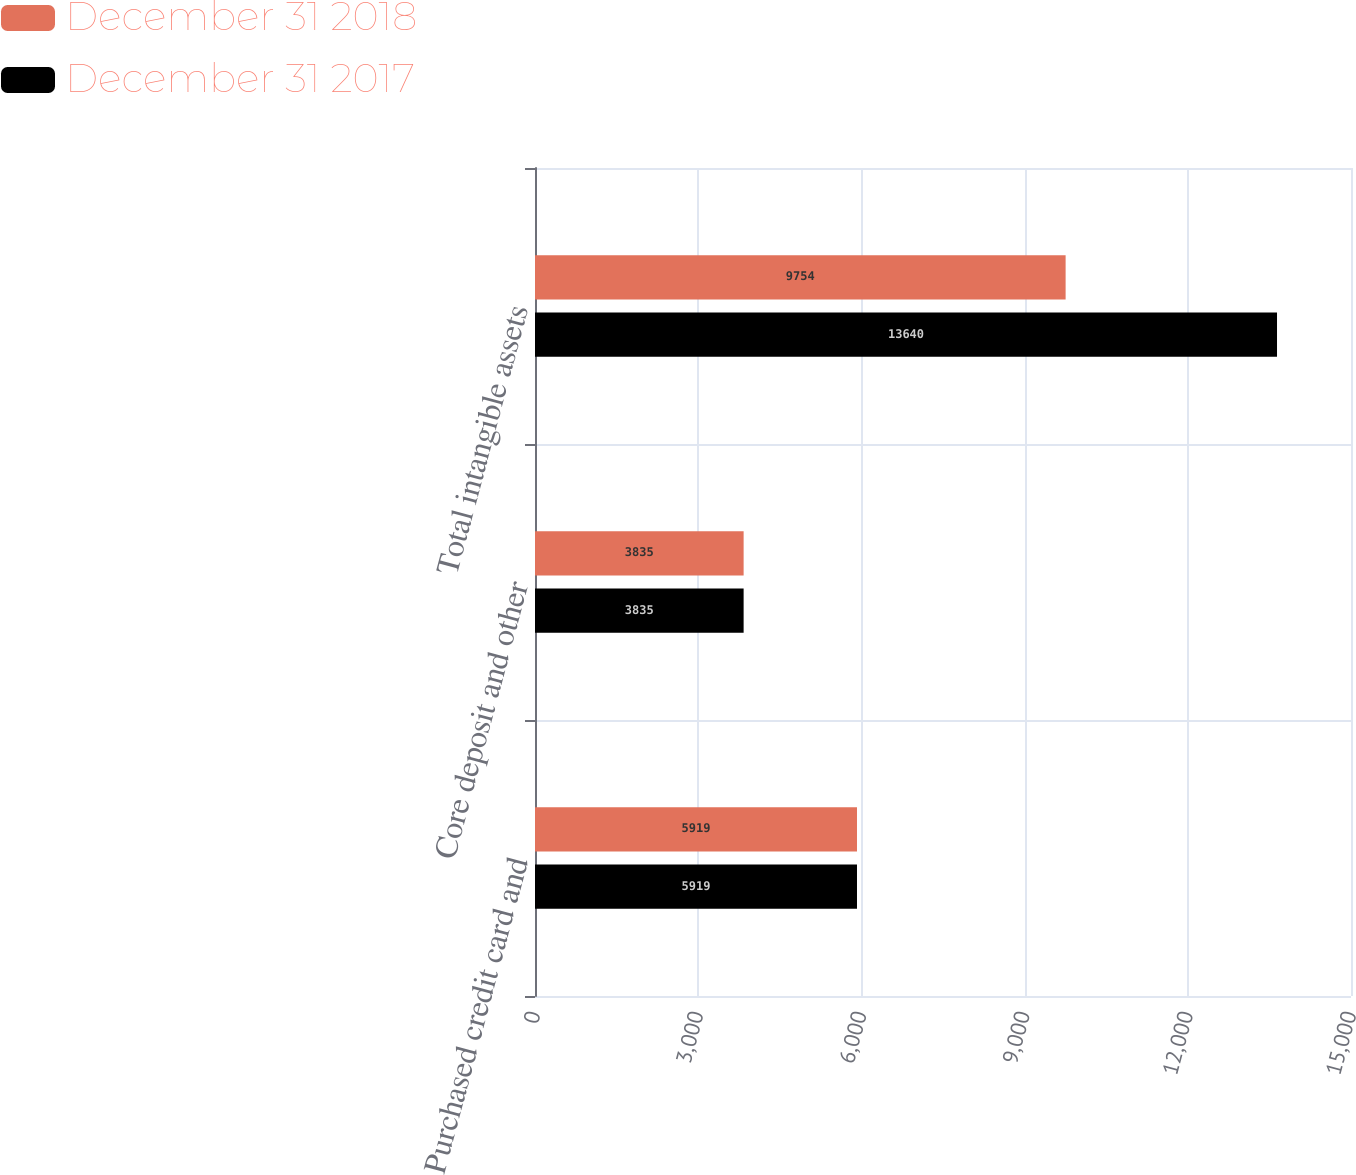Convert chart. <chart><loc_0><loc_0><loc_500><loc_500><stacked_bar_chart><ecel><fcel>Purchased credit card and<fcel>Core deposit and other<fcel>Total intangible assets<nl><fcel>December 31 2018<fcel>5919<fcel>3835<fcel>9754<nl><fcel>December 31 2017<fcel>5919<fcel>3835<fcel>13640<nl></chart> 